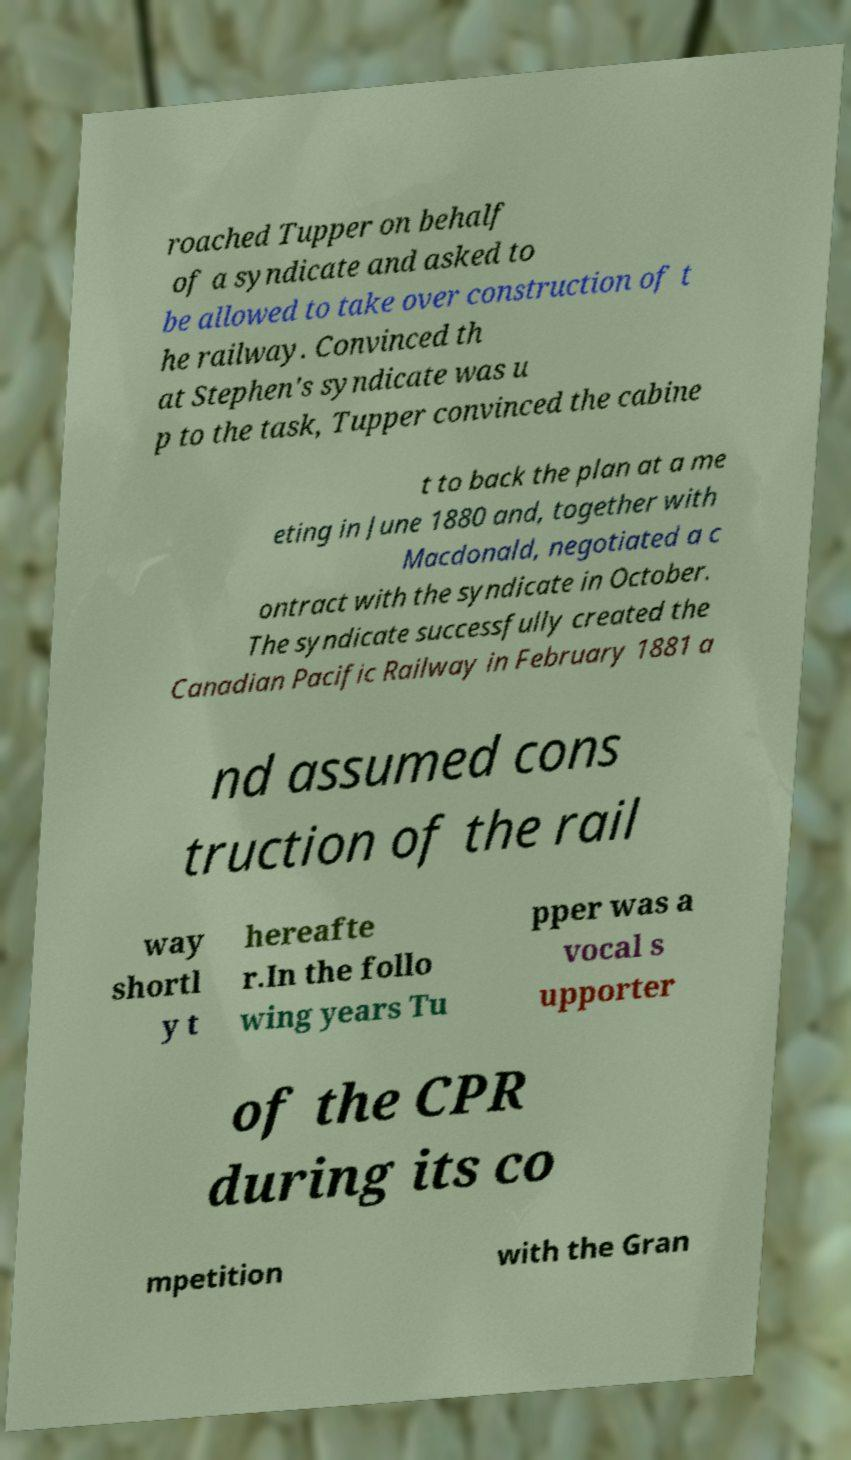Please identify and transcribe the text found in this image. roached Tupper on behalf of a syndicate and asked to be allowed to take over construction of t he railway. Convinced th at Stephen's syndicate was u p to the task, Tupper convinced the cabine t to back the plan at a me eting in June 1880 and, together with Macdonald, negotiated a c ontract with the syndicate in October. The syndicate successfully created the Canadian Pacific Railway in February 1881 a nd assumed cons truction of the rail way shortl y t hereafte r.In the follo wing years Tu pper was a vocal s upporter of the CPR during its co mpetition with the Gran 